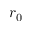<formula> <loc_0><loc_0><loc_500><loc_500>r _ { 0 }</formula> 